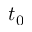Convert formula to latex. <formula><loc_0><loc_0><loc_500><loc_500>t _ { 0 }</formula> 